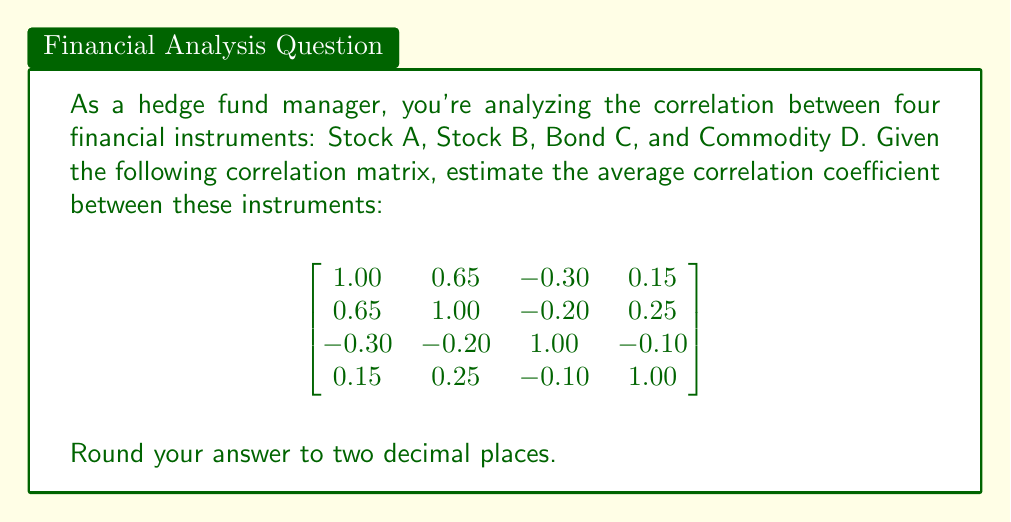Show me your answer to this math problem. To estimate the average correlation coefficient:

1) Count the number of unique correlation coefficients:
   $n = \frac{4(4-1)}{2} = 6$ (excluding diagonal elements)

2) Sum the unique correlation coefficients:
   $0.65 + (-0.30) + 0.15 + (-0.20) + 0.25 + (-0.10) = 0.45$

3) Calculate the average:
   $\frac{0.45}{6} = 0.075$

4) Round to two decimal places:
   $0.075 \approx 0.08$

This average provides a quick estimate of the overall correlation between the instruments, which is slightly positive but close to zero, indicating weak overall correlation.
Answer: 0.08 